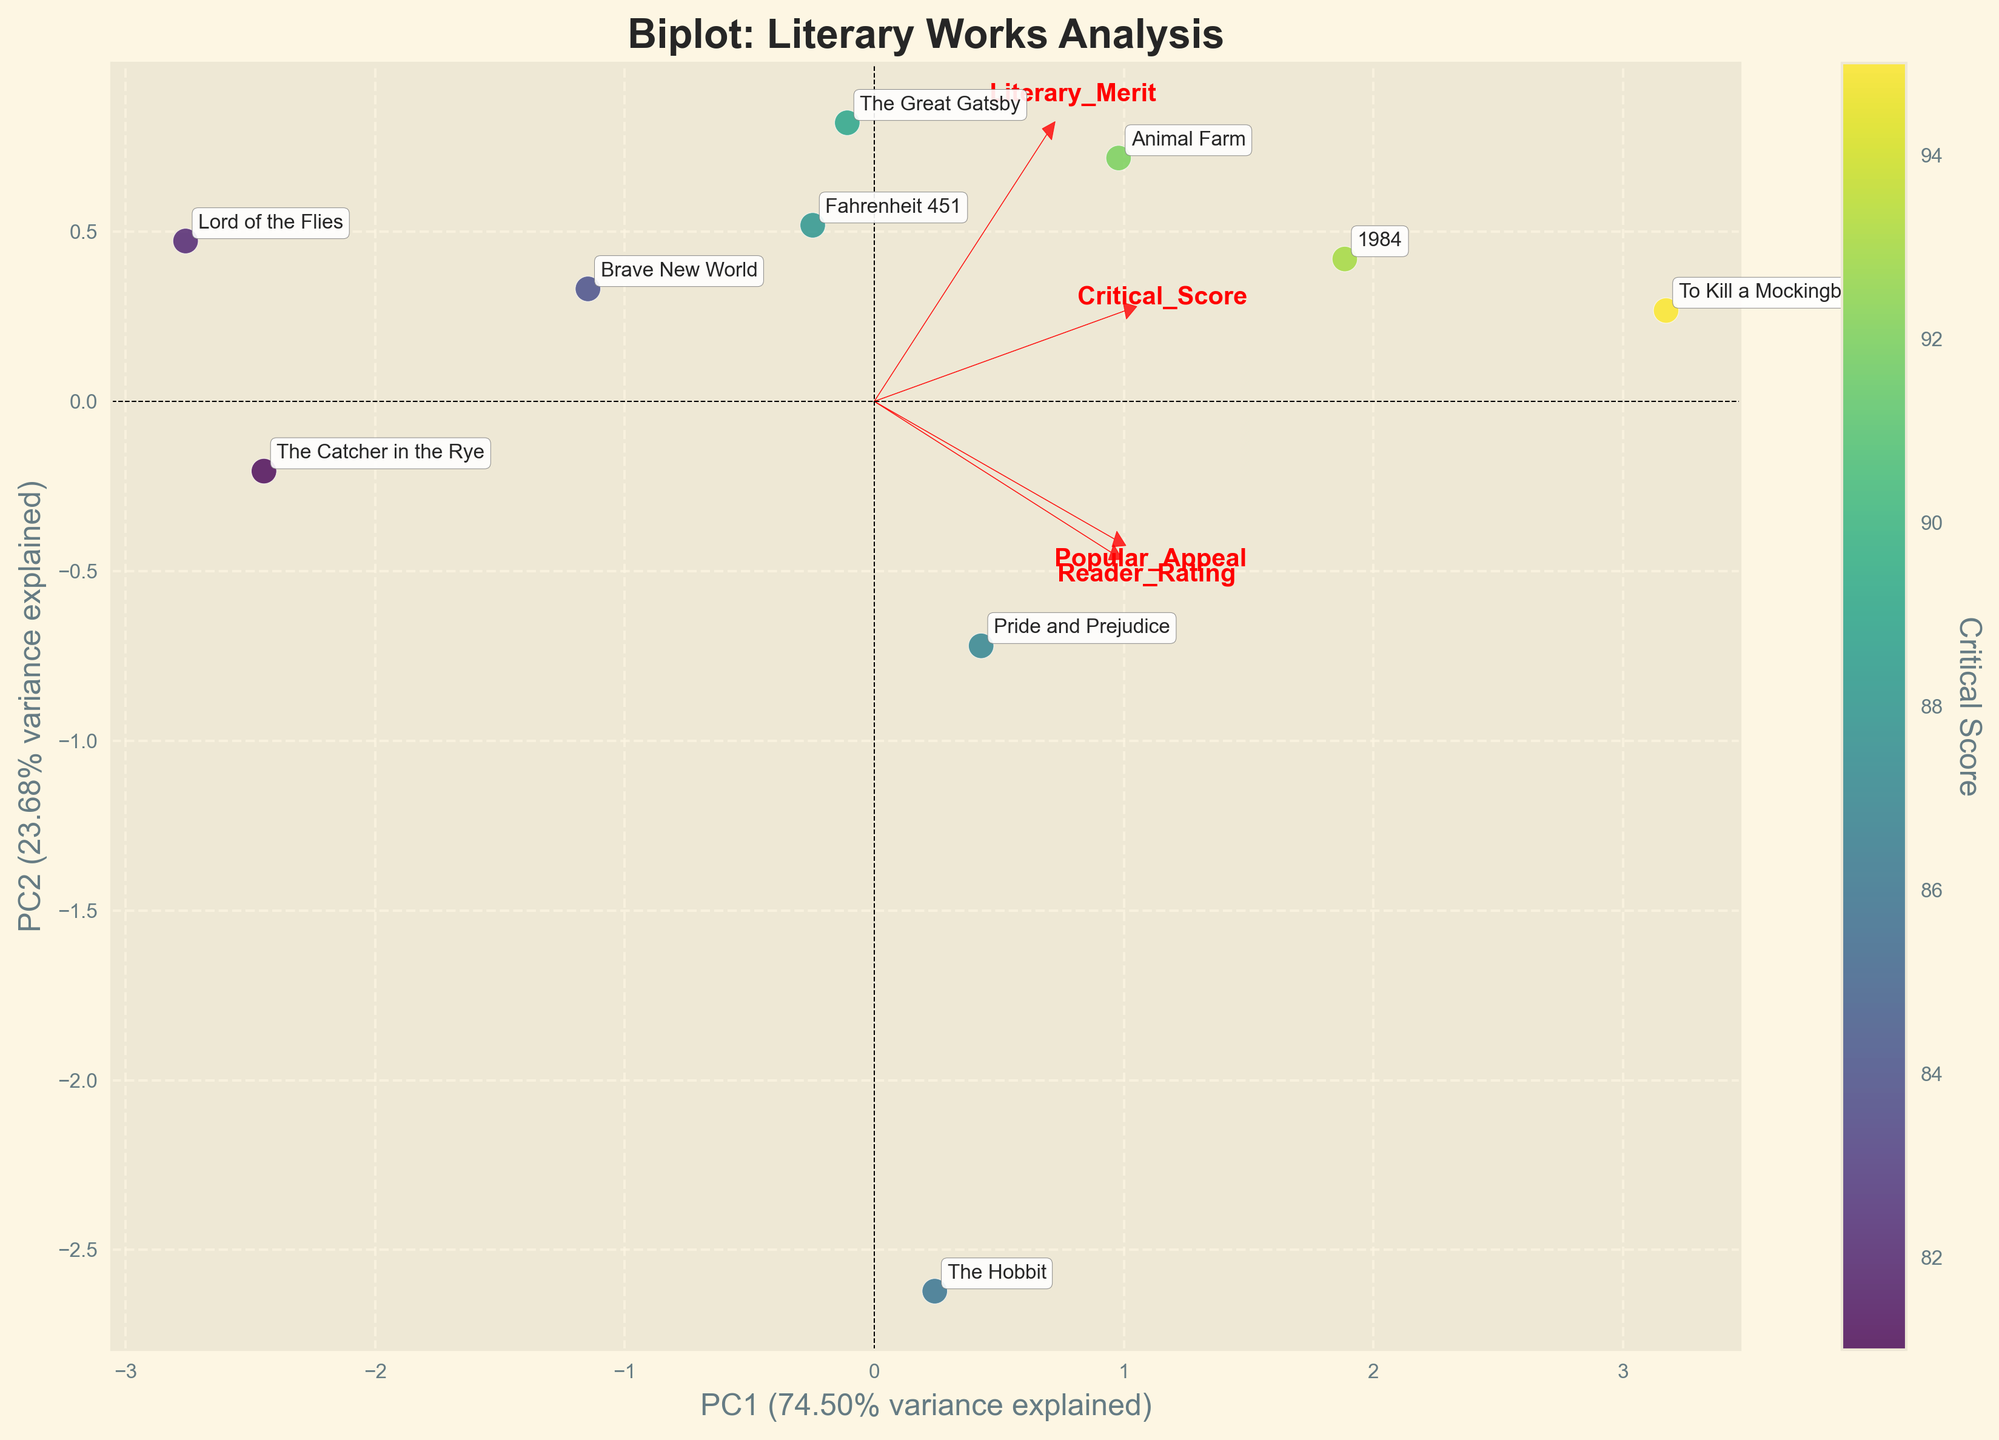Which work has the highest critical score? By looking at the color intensity on the scatter points, we can observe which work has the highest hue indicating a higher critical score.
Answer: To Kill a Mockingbird How much variance is explained by the first principal component (PC1)? The label on the x-axis indicates the percentage of variance explained by PC1.
Answer: 49.8% Which feature has a stronger positive influence on PC1 compared to PC2? By examining the direction and length of the red arrows, we can see which feature vector is more aligned with the PC1 axis.
Answer: Literary Merit Which work has the lowest reader rating according to its position on the plot? Locate the work that is closest to the bottom along the y-axis (related to Reader Rating).
Answer: Lord of the Flies How does 'The Great Gatsby' compare to '1984' in terms of popular appeal based on their loadings? Compare their positions relative to the Popular Appeal arrow. '1984' is positioned further in the direction of the Popular Appeal vector than 'The Great Gatsby'.
Answer: '1984' is higher Which literary work is most closely aligned with the arrow for Popular Appeal? Look for the data point that is nearest and most oriented towards the Popular Appeal vector.
Answer: To Kill a Mockingbird What's the relationship between 'Animal Farm' and 'The Hobbit' in terms of the critical score? Compare the color intensity of the two points representing the works.
Answer: Animal Farm has a higher critical score Are there any works that score higher on the second principal component (PC2) but lower on PC1? Identify points that are positioned higher along the y-axis (PC2) yet towards the left on the x-axis (PC1).
Answer: Lord of the Flies Do 'Fahrenheit 451' and 'Brave New World' heavily load on Literary Merit and Popular Appeal? Check the alignment of these works concerning the red vectors for Literary Merit and Popular Appeal. Both works lie nearly on the direction vectors for Literary Merit, indicating a strong loading.
Answer: Yes 